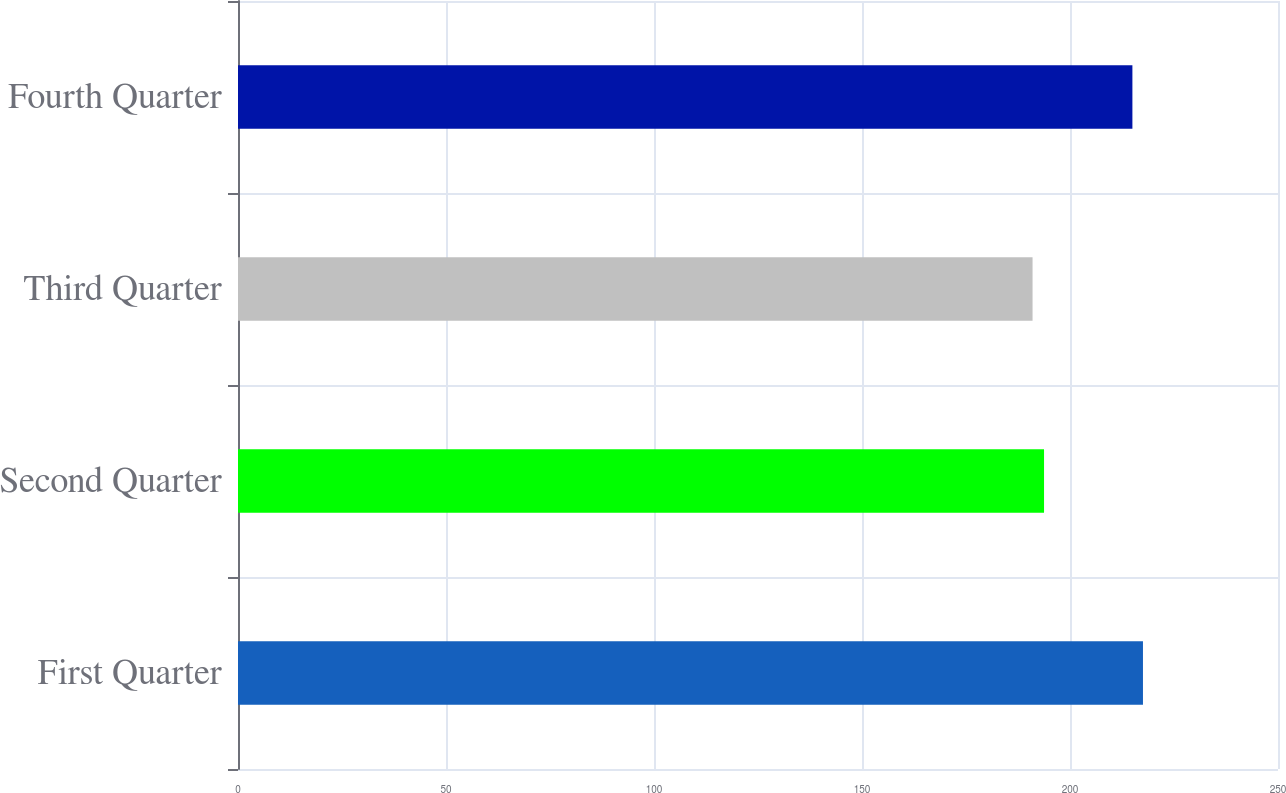Convert chart to OTSL. <chart><loc_0><loc_0><loc_500><loc_500><bar_chart><fcel>First Quarter<fcel>Second Quarter<fcel>Third Quarter<fcel>Fourth Quarter<nl><fcel>217.54<fcel>193.76<fcel>191<fcel>215<nl></chart> 